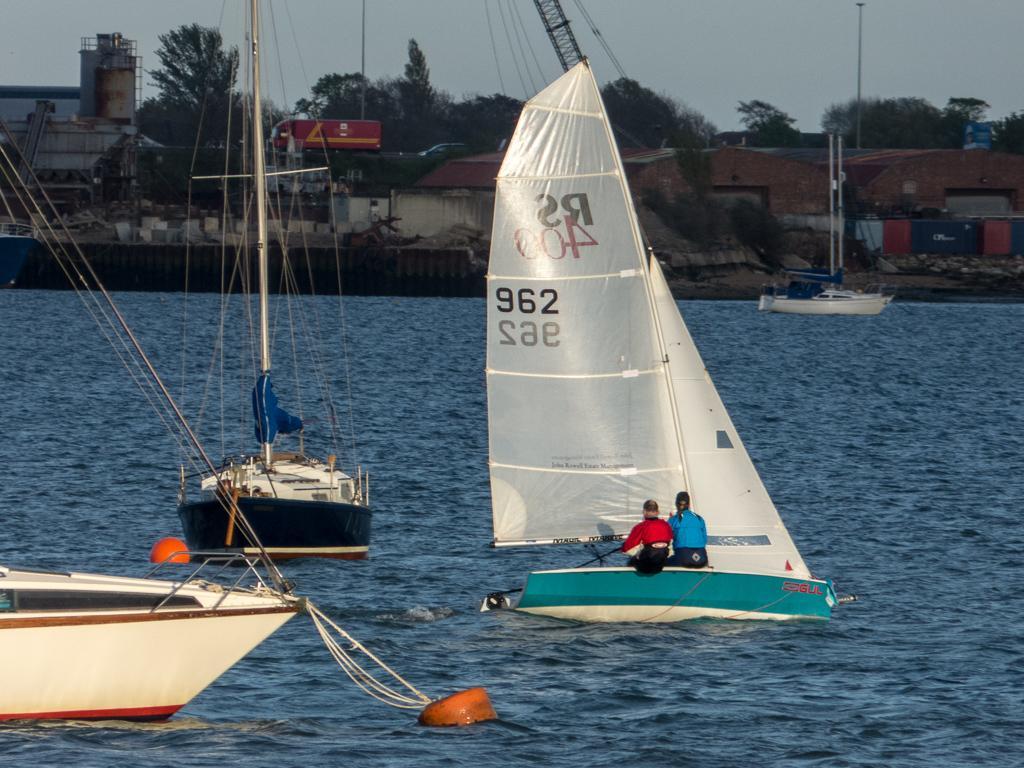How would you summarize this image in a sentence or two? In this image, on the right there is a boat in that there are two people. On the left there are two boats. At the bottom there are waves, water. In the background there are buildings, boat, trees, poles, clothes, sky. 